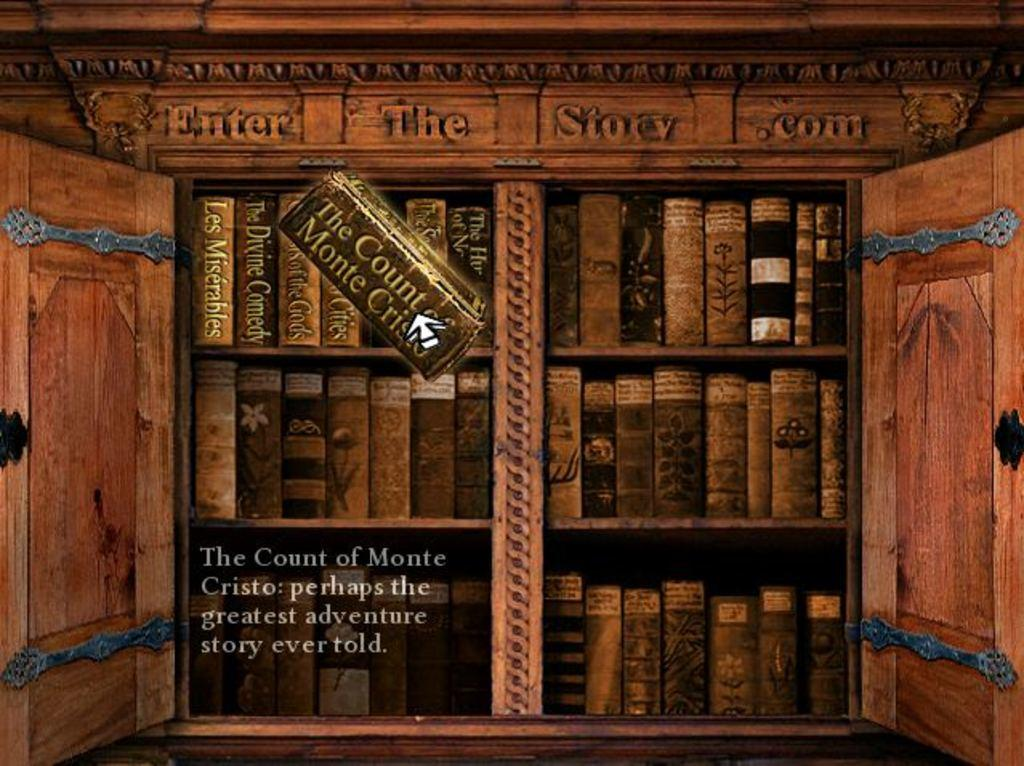What can be seen hanging on the wall in the image? There is a poster in the image. Where are the books located in the image? The books are in a cupboard in the image. What is written on the cupboard? There is text on the cupboard. What text can be found at the bottom of the image? There is text at the bottom of the image. Can you tell me how many hens are sitting on the poster in the image? There are no hens present on the poster in the image. What type of screw is used to hold the cupboard together in the image? There is no information about screws in the image; it only mentions the presence of a cupboard and text on it. 